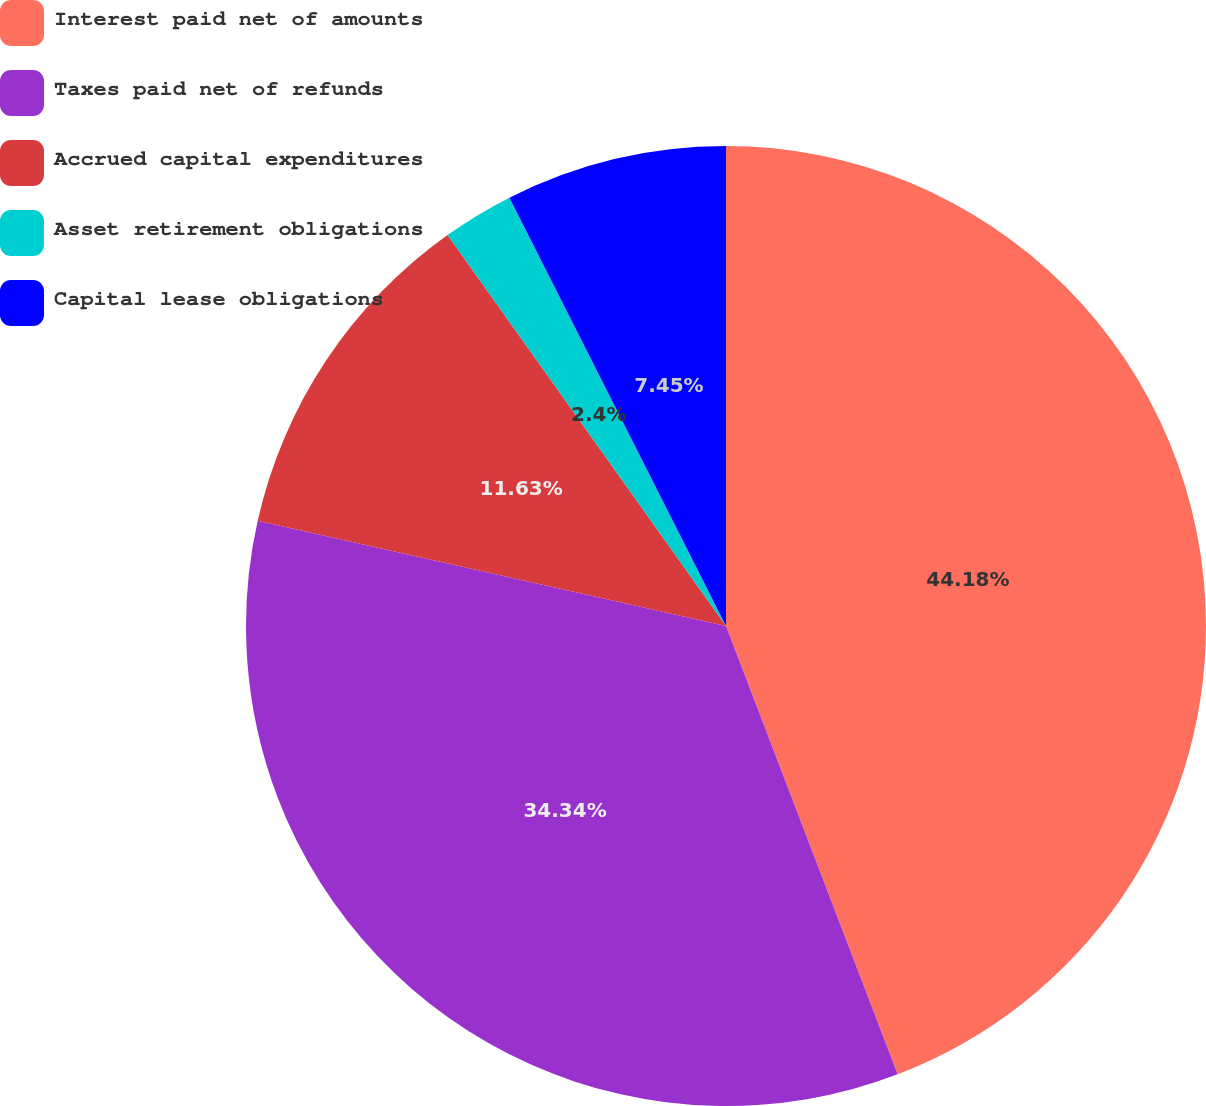<chart> <loc_0><loc_0><loc_500><loc_500><pie_chart><fcel>Interest paid net of amounts<fcel>Taxes paid net of refunds<fcel>Accrued capital expenditures<fcel>Asset retirement obligations<fcel>Capital lease obligations<nl><fcel>44.18%<fcel>34.34%<fcel>11.63%<fcel>2.4%<fcel>7.45%<nl></chart> 